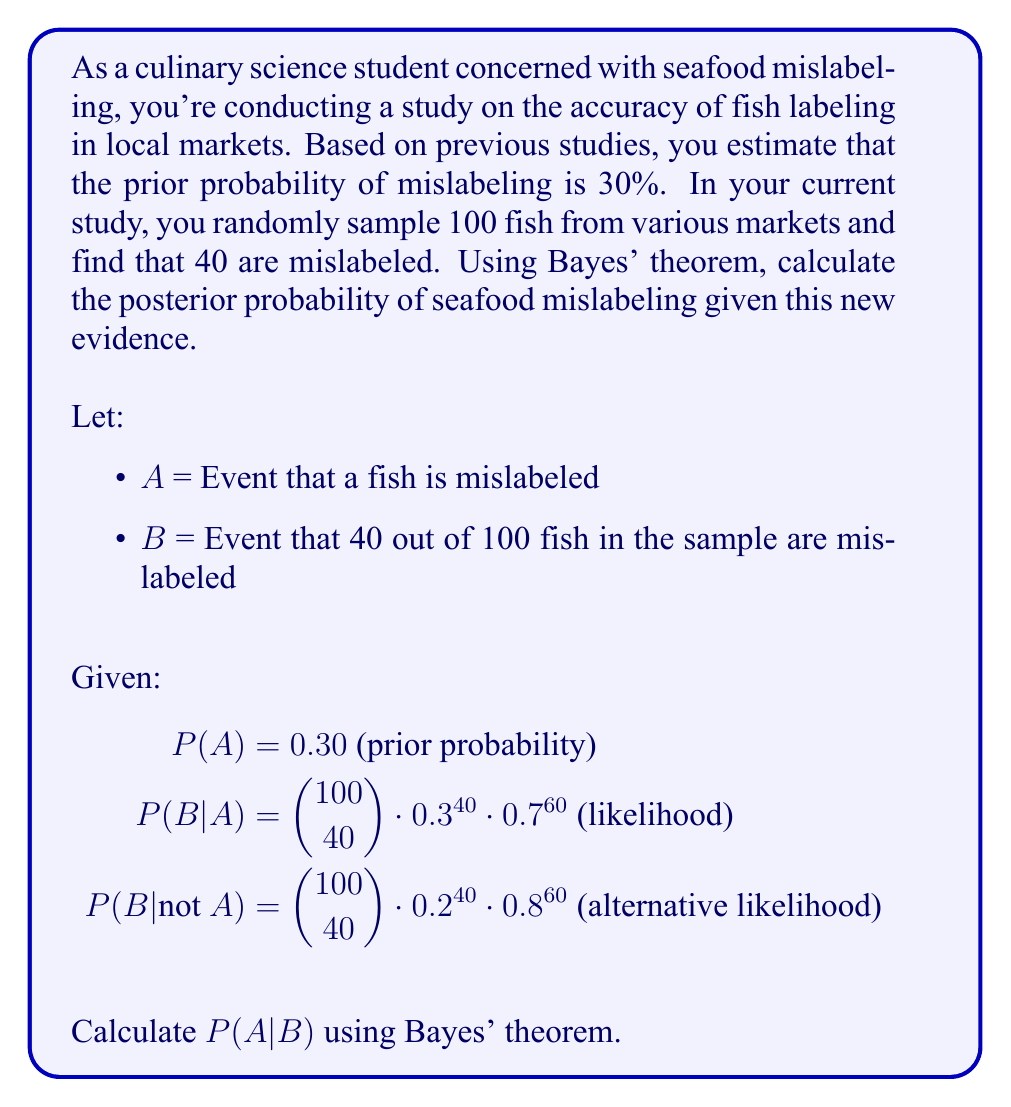Help me with this question. To solve this problem, we'll use Bayes' theorem:

$$P(A|B) = \frac{P(B|A) \cdot P(A)}{P(B)}$$

Step 1: Calculate P(B|A) and P(B|not A)
P(B|A) = $\binom{100}{40} \cdot 0.3^{40} \cdot 0.7^{60} \approx 0.0461$
P(B|not A) = $\binom{100}{40} \cdot 0.2^{40} \cdot 0.8^{60} \approx 0.0002$

Step 2: Calculate P(B) using the law of total probability
$$P(B) = P(B|A) \cdot P(A) + P(B|not A) \cdot P(not A)$$
$$P(B) = 0.0461 \cdot 0.30 + 0.0002 \cdot 0.70 \approx 0.01383 + 0.00014 = 0.01397$$

Step 3: Apply Bayes' theorem
$$P(A|B) = \frac{0.0461 \cdot 0.30}{0.01397} \approx 0.9899$$

Step 4: Convert to percentage
0.9899 * 100% ≈ 98.99%
Answer: 98.99% 